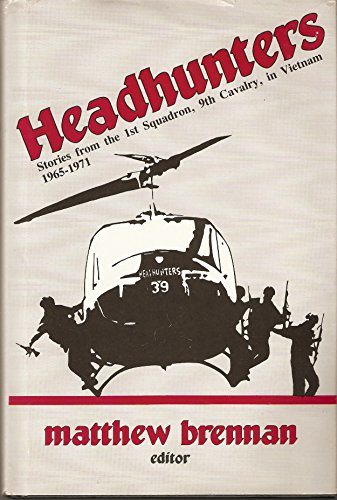What is the title of this book? The title of this book is 'Headhunters: Stories from the 1st Squadron, 9th Cavalry in Vietnam, 1965-1971,' which hints at the harrowing experiences and stories contained within this compelling historical account. 